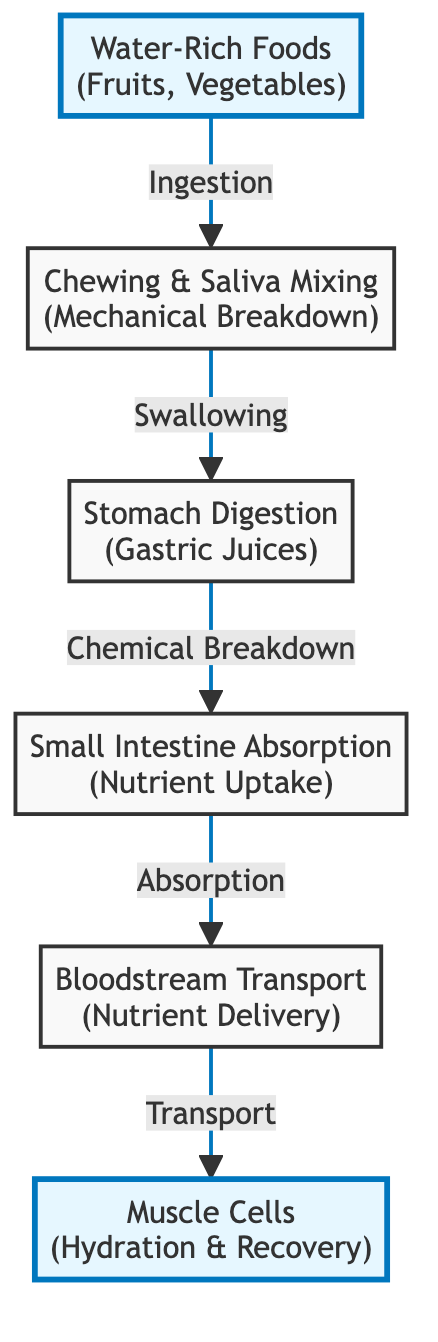What is the first step in the hydration hierarchy? The diagram shows that the first step in the hydration hierarchy involves the ingestion of water-rich foods, such as fruits and vegetables.
Answer: Water-Rich Foods (Fruits, Vegetables) How many nodes are in the diagram? By counting the nodes visually in the diagram, there are a total of six distinct steps depicted in the flowchart.
Answer: 6 What is the role of the small intestine in this process? The small intestine is responsible for the absorption of nutrients, which follows the chemical breakdown that occurs in the stomach.
Answer: Absorption What connects the stomach digestion to the small intestine absorption? The connecting relationship is that stomach digestion involves chemical breakdown, which leads directly to the absorption stage in the small intestine.
Answer: Chemical Breakdown What is delivered to muscle cells in this hierarchy? The diagram indicates that the bloodstream transports nutrients to the muscle cells, which are essential for hydration and recovery.
Answer: Nutrients Which two components are related by the process of swallowing? The process of swallowing connects chewing and saliva mixing to stomach digestion, indicating the transition from mechanical breakdown to chemical processing.
Answer: Chewing & Saliva Mixing, Stomach Digestion What step involves nutrient delivery? The bloodstream transport stage is where nutrient delivery occurs after absorption in the small intestine.
Answer: Bloodstream Transport Explain how water-rich foods contribute to muscle hydration Water-rich foods are consumed first, then through chewing and saliva mixing, they are mechanically broken down, leading to further digestion and nutrient absorption in the body, which ultimately supports hydration in muscle cells.
Answer: Muscle Cells (Hydration & Recovery) 